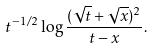Convert formula to latex. <formula><loc_0><loc_0><loc_500><loc_500>t ^ { - 1 / 2 } \log \frac { ( \sqrt { t } + \sqrt { x } ) ^ { 2 } } { t - x } .</formula> 